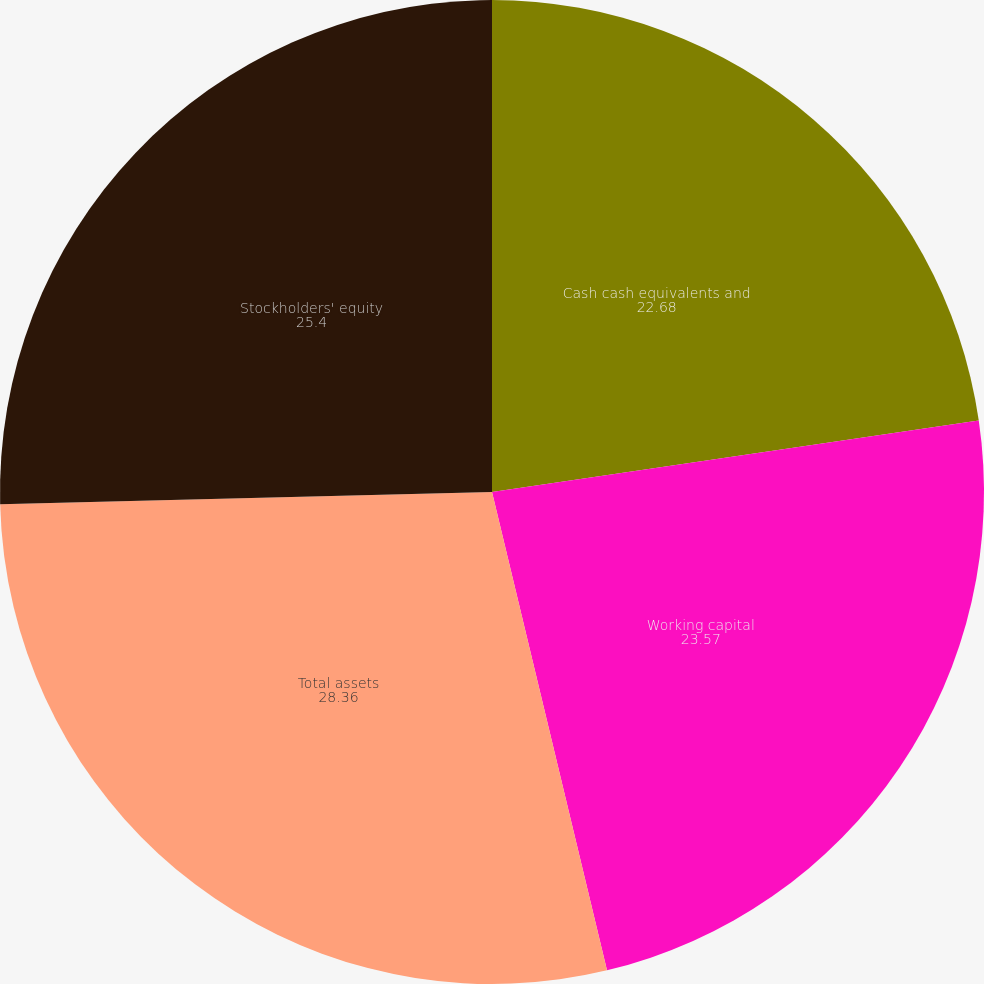Convert chart to OTSL. <chart><loc_0><loc_0><loc_500><loc_500><pie_chart><fcel>Cash cash equivalents and<fcel>Working capital<fcel>Total assets<fcel>Stockholders' equity<nl><fcel>22.68%<fcel>23.57%<fcel>28.36%<fcel>25.4%<nl></chart> 